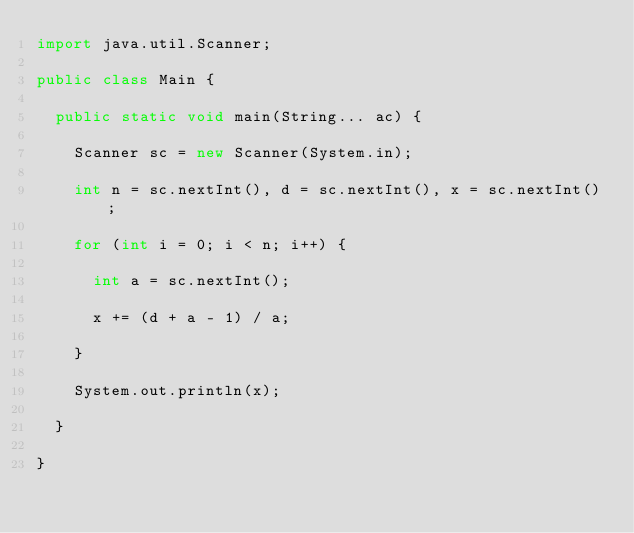Convert code to text. <code><loc_0><loc_0><loc_500><loc_500><_Java_>import java.util.Scanner;

public class Main {
	
	public static void main(String... ac) {
		
		Scanner sc = new Scanner(System.in);
		
		int n = sc.nextInt(), d = sc.nextInt(), x = sc.nextInt();
		
		for (int i = 0; i < n; i++) {
			
			int a = sc.nextInt();
			
			x += (d + a - 1) / a;
			
		}
		
		System.out.println(x);
		
	}
	
}</code> 